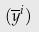Convert formula to latex. <formula><loc_0><loc_0><loc_500><loc_500>( \overline { y } ^ { i } )</formula> 